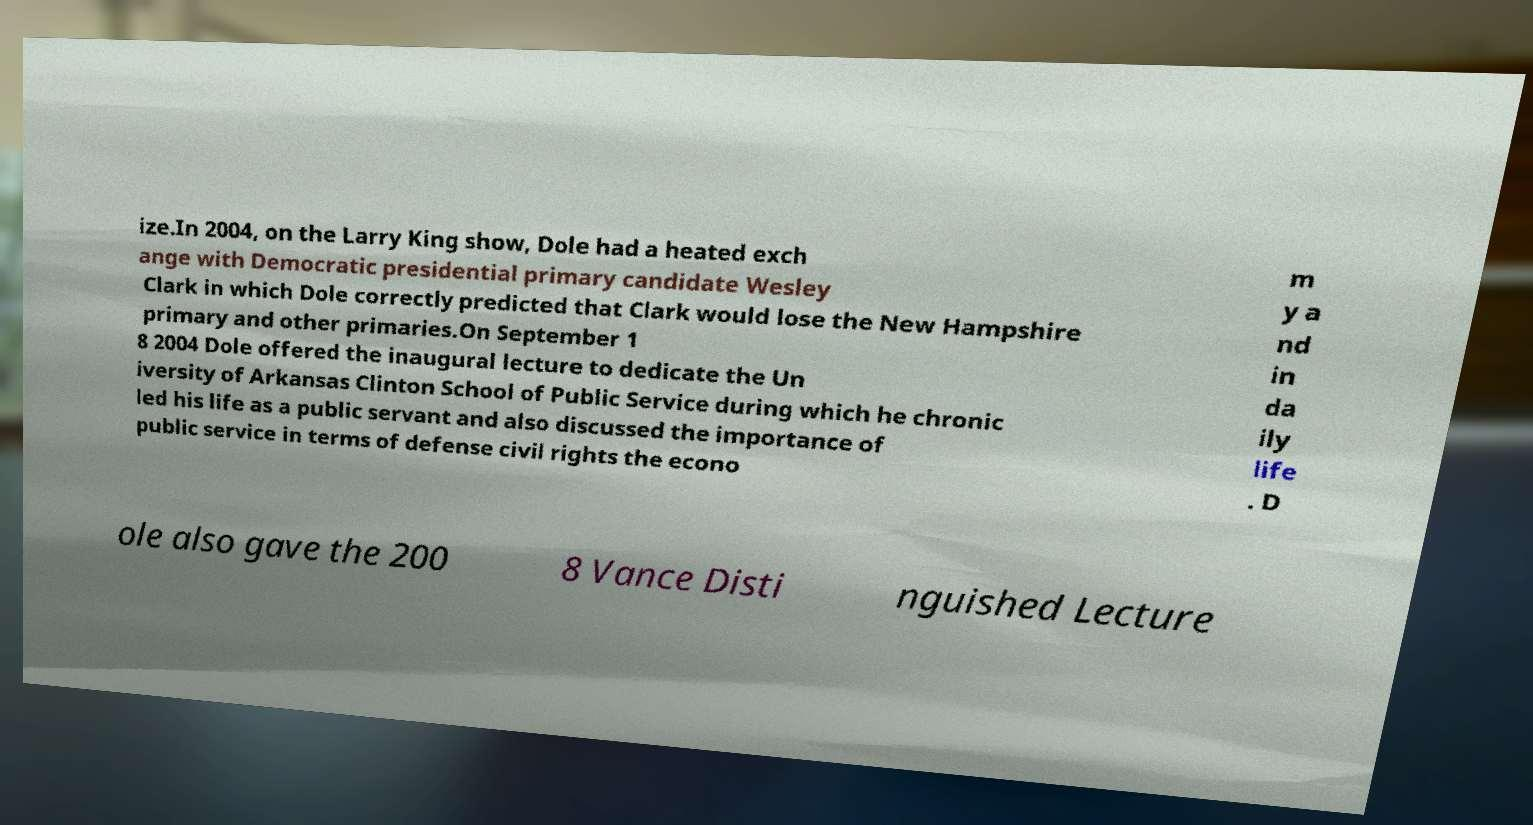Could you assist in decoding the text presented in this image and type it out clearly? ize.In 2004, on the Larry King show, Dole had a heated exch ange with Democratic presidential primary candidate Wesley Clark in which Dole correctly predicted that Clark would lose the New Hampshire primary and other primaries.On September 1 8 2004 Dole offered the inaugural lecture to dedicate the Un iversity of Arkansas Clinton School of Public Service during which he chronic led his life as a public servant and also discussed the importance of public service in terms of defense civil rights the econo m y a nd in da ily life . D ole also gave the 200 8 Vance Disti nguished Lecture 